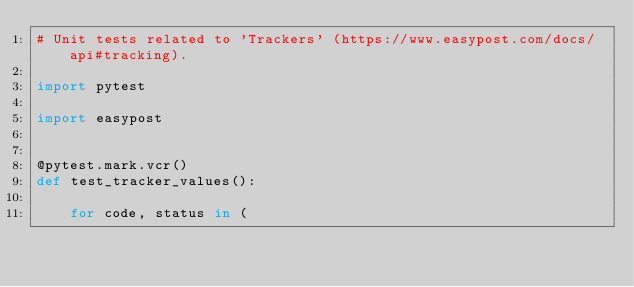Convert code to text. <code><loc_0><loc_0><loc_500><loc_500><_Python_># Unit tests related to 'Trackers' (https://www.easypost.com/docs/api#tracking).

import pytest

import easypost


@pytest.mark.vcr()
def test_tracker_values():

    for code, status in (</code> 